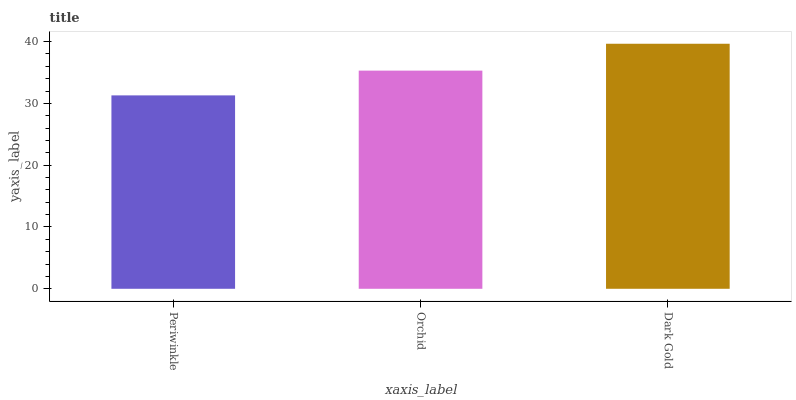Is Orchid the minimum?
Answer yes or no. No. Is Orchid the maximum?
Answer yes or no. No. Is Orchid greater than Periwinkle?
Answer yes or no. Yes. Is Periwinkle less than Orchid?
Answer yes or no. Yes. Is Periwinkle greater than Orchid?
Answer yes or no. No. Is Orchid less than Periwinkle?
Answer yes or no. No. Is Orchid the high median?
Answer yes or no. Yes. Is Orchid the low median?
Answer yes or no. Yes. Is Periwinkle the high median?
Answer yes or no. No. Is Dark Gold the low median?
Answer yes or no. No. 